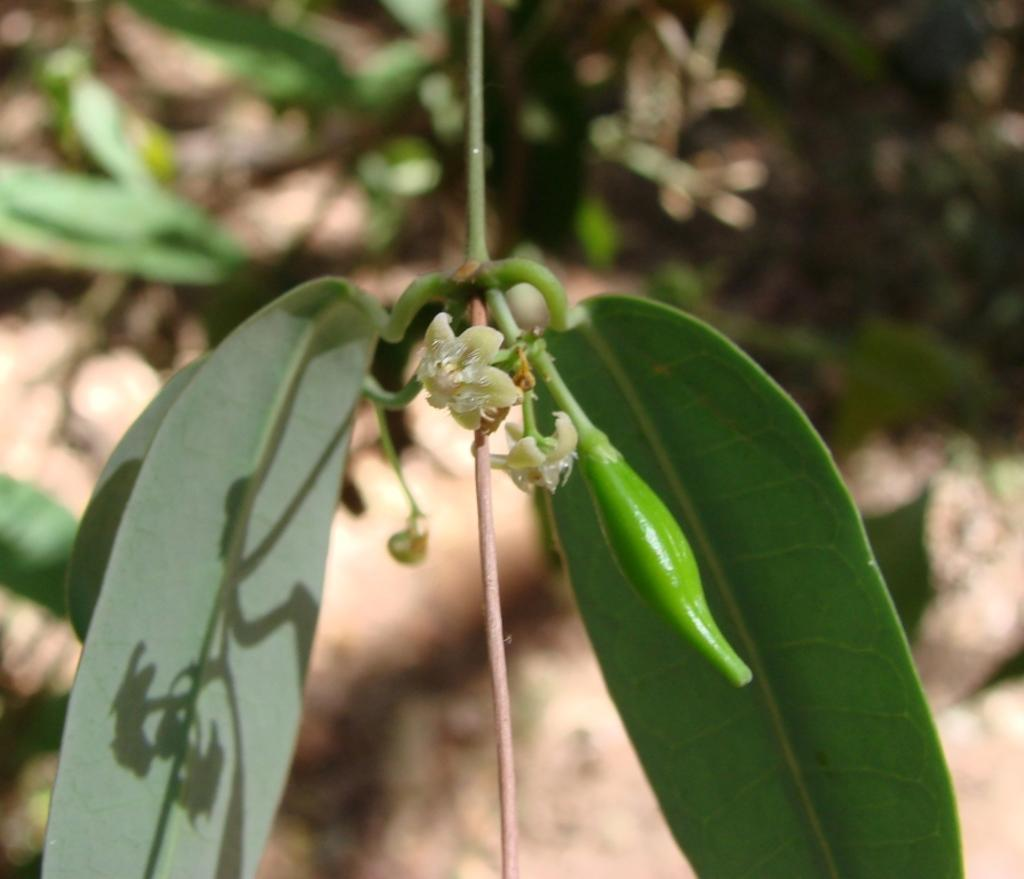What type of vegetation can be seen in the image? There are leaves in the image. What part of a tree is visible in the image? There is a branch in the image. How would you describe the background of the image? The background of the image is blurry. What type of jeans is the person wearing in the image? There is no person or jeans present in the image; it only features leaves and a branch. 